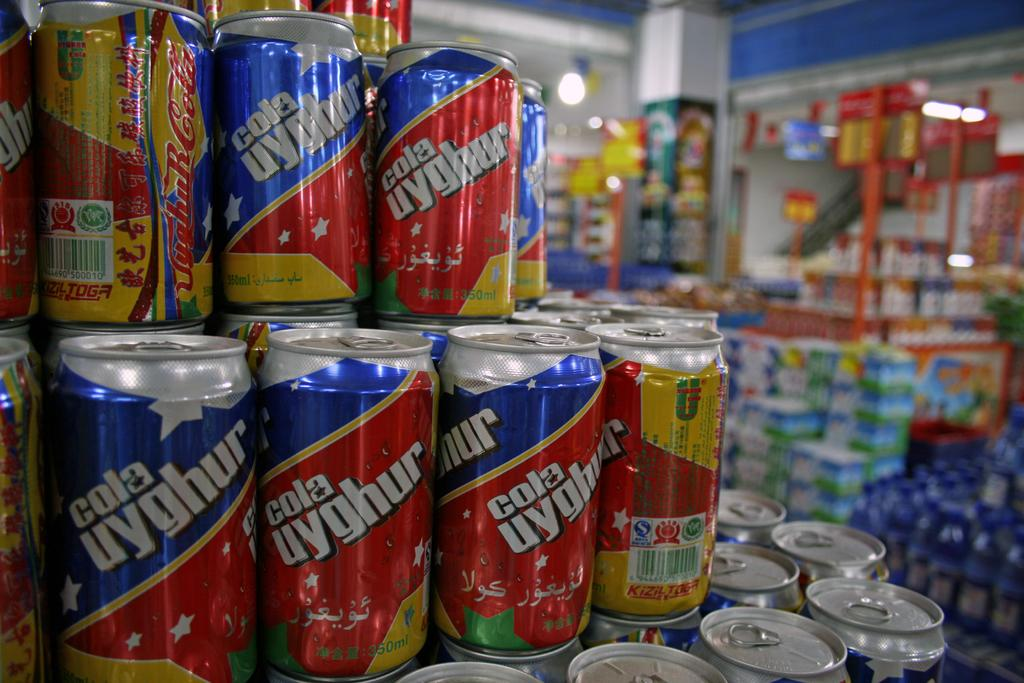Provide a one-sentence caption for the provided image.  cola uyghur cans displayed close up for sale at a store. 